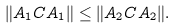<formula> <loc_0><loc_0><loc_500><loc_500>\| A _ { 1 } C A _ { 1 } \| \leq \| A _ { 2 } C A _ { 2 } \| .</formula> 